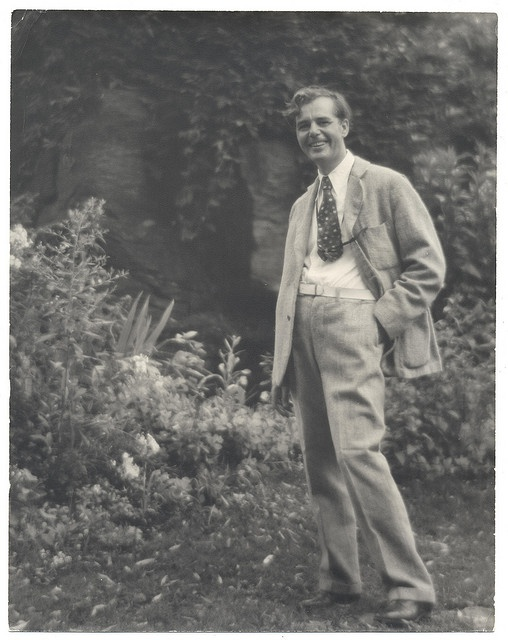Describe the objects in this image and their specific colors. I can see people in white, darkgray, gray, and lightgray tones and tie in white, gray, and darkgray tones in this image. 